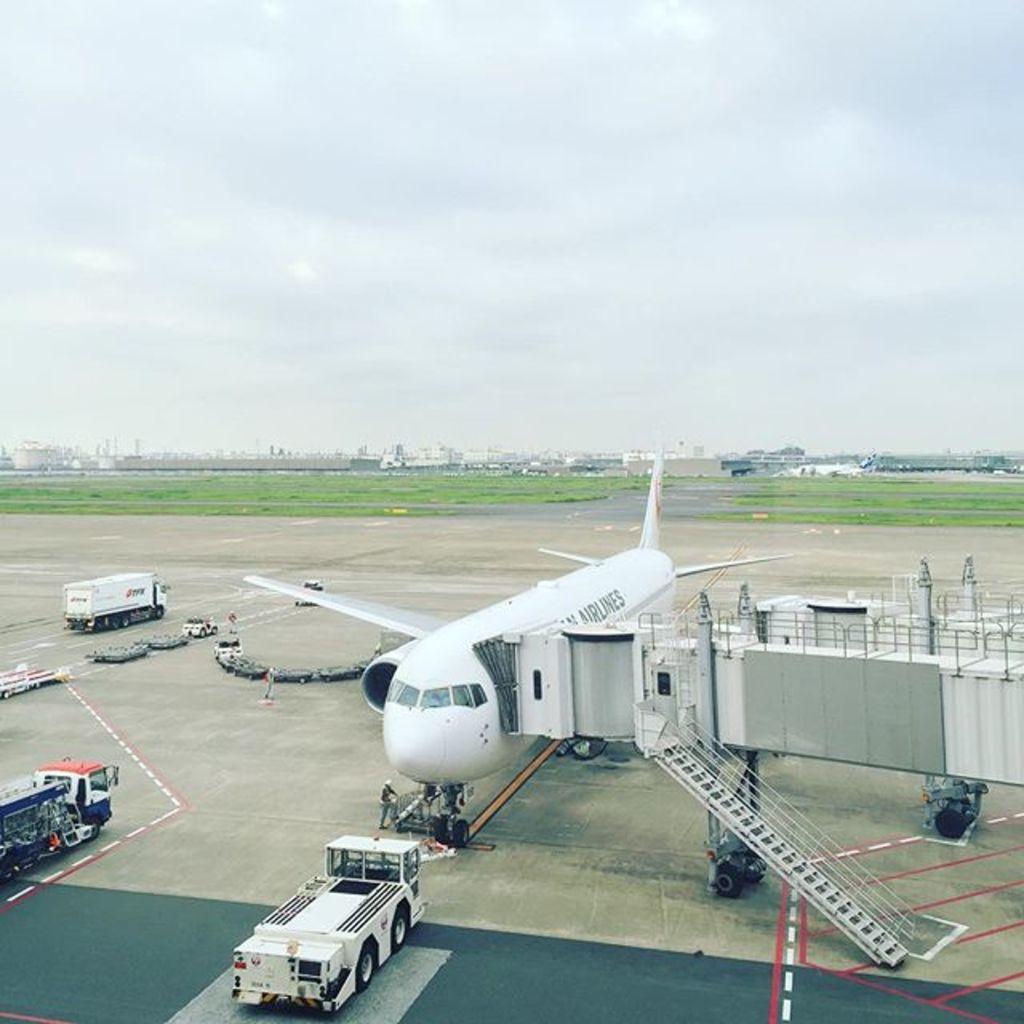Can you describe this image briefly? In this picture we can see an airplane, vehicles, staircase, person standing and some objects on the ground and in the background we can see the grass, buildings, sky. 